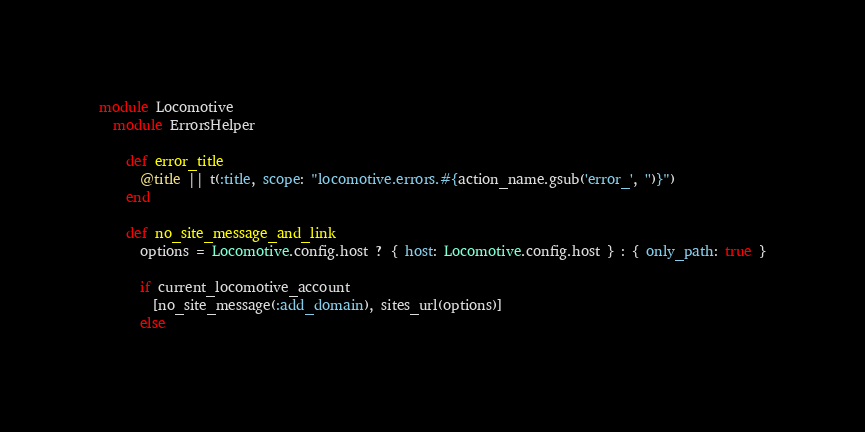<code> <loc_0><loc_0><loc_500><loc_500><_Ruby_>module Locomotive
  module ErrorsHelper

    def error_title
      @title || t(:title, scope: "locomotive.errors.#{action_name.gsub('error_', '')}")
    end

    def no_site_message_and_link
      options = Locomotive.config.host ? { host: Locomotive.config.host } : { only_path: true }

      if current_locomotive_account
        [no_site_message(:add_domain), sites_url(options)]
      else</code> 